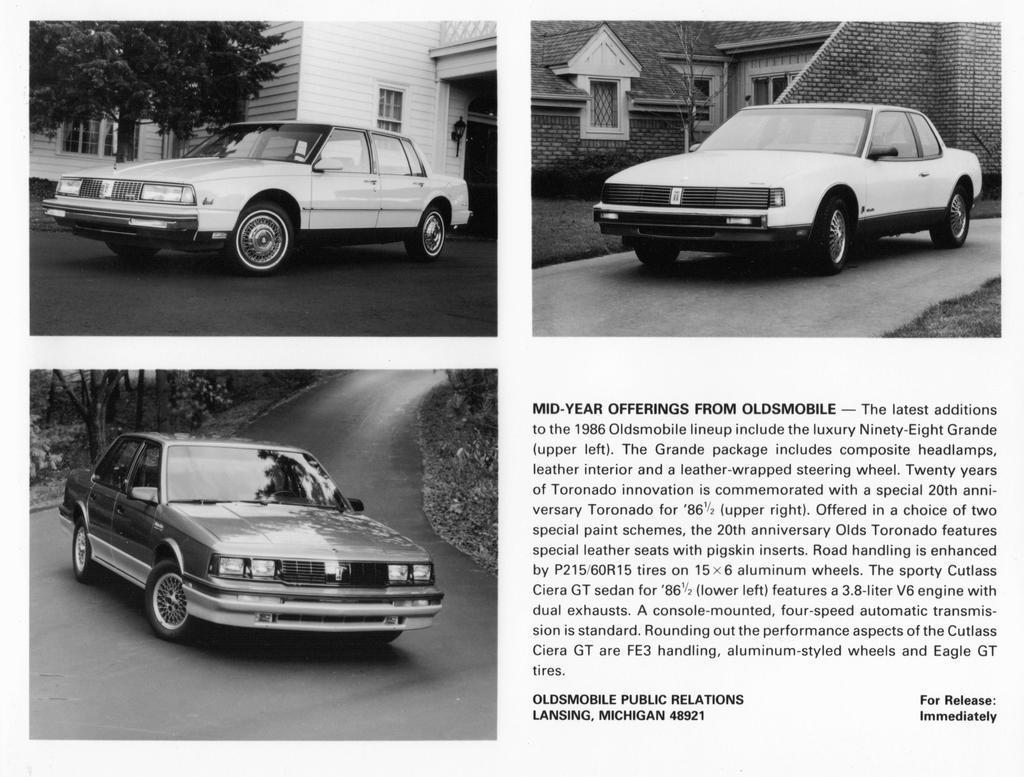Can you describe this image briefly? In the image we can see some cars on the road. Behind the cars there are some trees and buildings. 